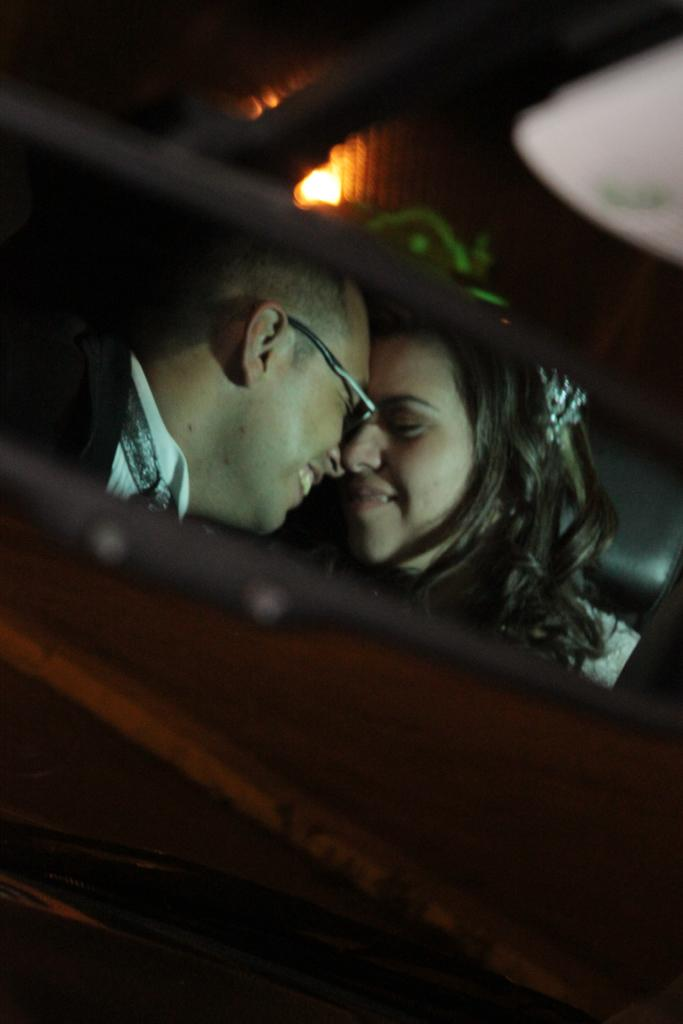How many people are in the image? There are two people in the image. What expression do the people in the image have? The two people are smiling. Can you describe the lighting in the image? There is light in the image. What can be seen in the image besides the people? There are objects in the image. What is the color of the background in the image? The background of the image is dark. Can you tell me who the creator of the umbrella in the image is? There is no umbrella present in the image, so it is not possible to determine who the creator of the umbrella might be. What type of account is associated with the people in the image? There is no reference to an account in the image, so it is not possible to determine what type of account might be associated with the people. 